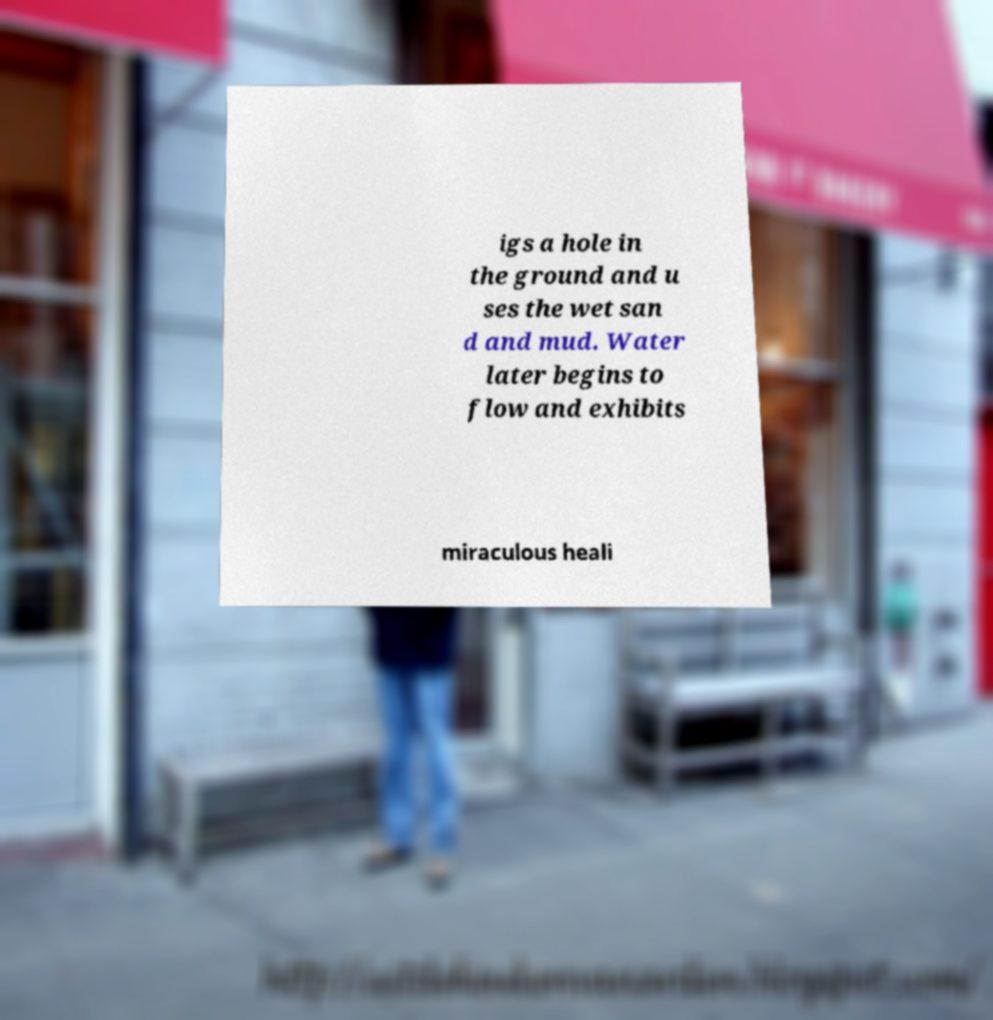For documentation purposes, I need the text within this image transcribed. Could you provide that? igs a hole in the ground and u ses the wet san d and mud. Water later begins to flow and exhibits miraculous heali 